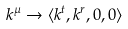Convert formula to latex. <formula><loc_0><loc_0><loc_500><loc_500>k ^ { \mu } \rightarrow \langle k ^ { t } , k ^ { r } , 0 , 0 \rangle</formula> 